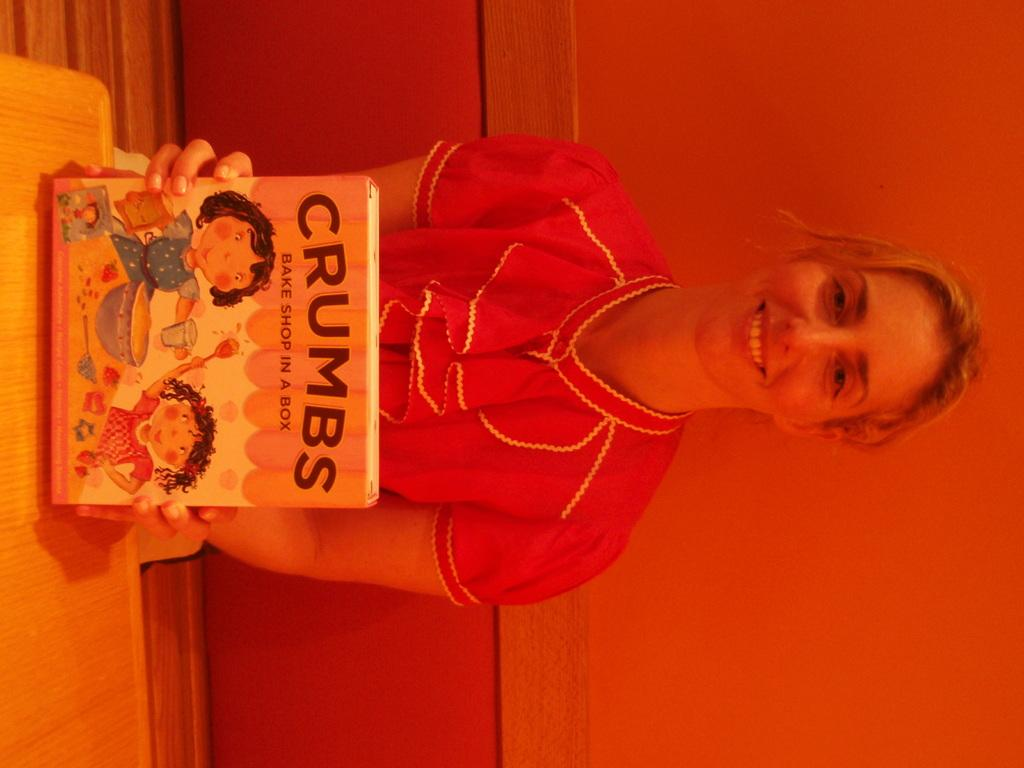Who is the main subject in the image? There is a lady in the image. What is the lady doing in the image? The lady is sitting on a bench and holding a book in her hands. What is the lady's facial expression in the image? The lady is smiling in the image. What type of record is the lady listening to in the image? There is no record present in the image; the lady is holding a book. What is the lady's interest in tomatoes in the image? There is no mention of tomatoes in the image; the lady is holding a book and smiling. 